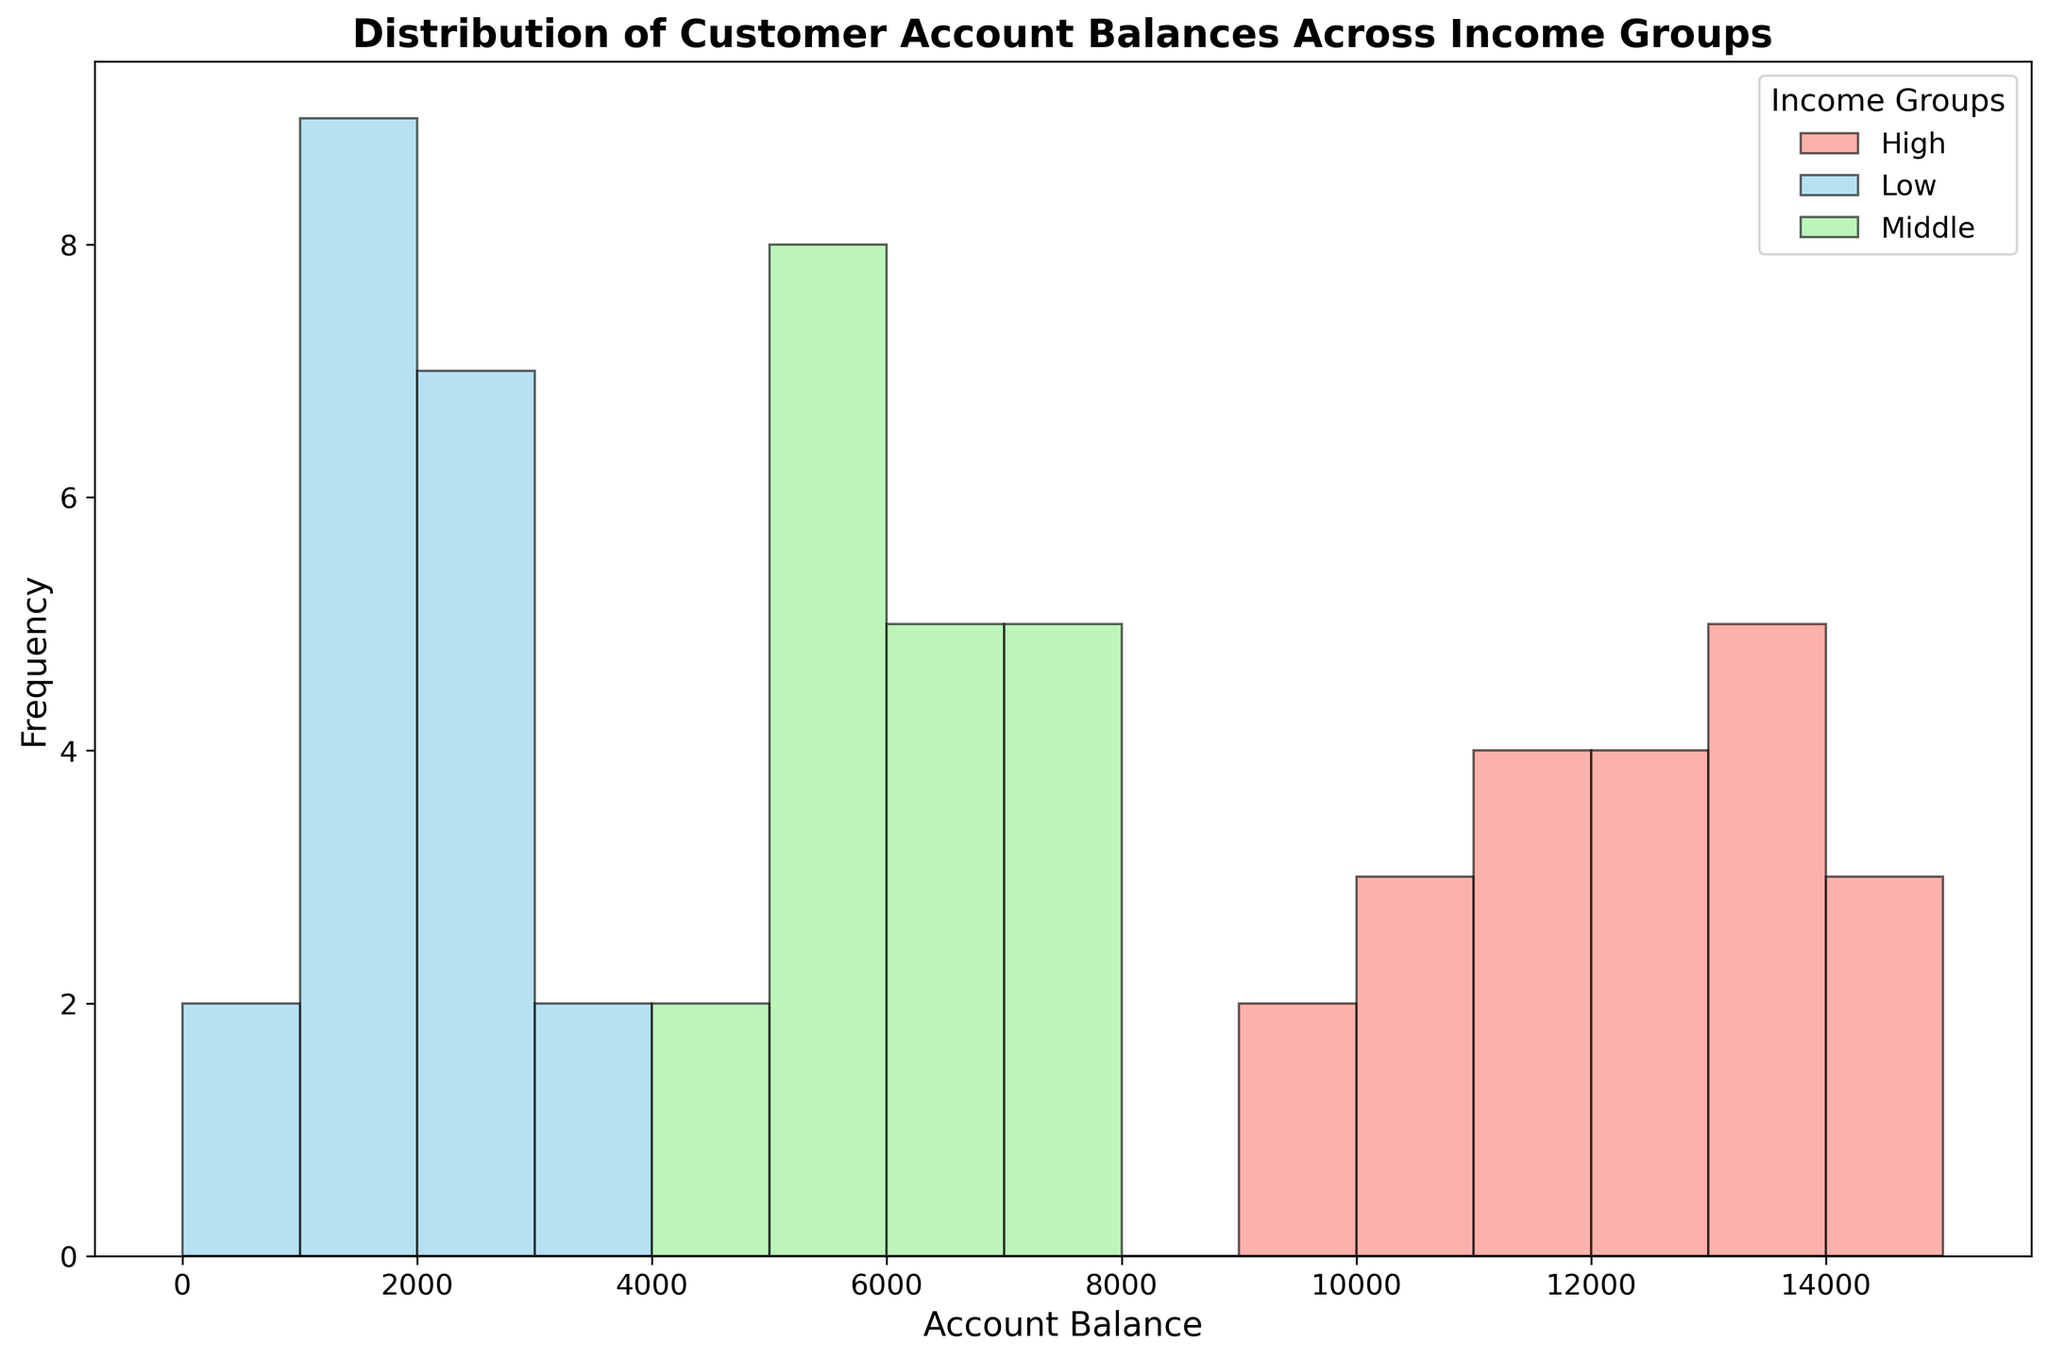What is the most frequent account balance range for the Low income group? To determine the most frequent account balance range, look at the tallest bars in the histogram for the Low income group (skyblue color). The tallest bars are between the 1000-2000 balance range.
Answer: 1000-2000 Which income group has the widest spread of account balances? To identify the widest spread, observe the range of account balances covered by each income group on the x-axis. The High income group (salmon color) covers balances from 9500 to 14500, which is the widest range.
Answer: High How does the peak frequency of the Middle income group's account balances compare to that of the Low income group? Compare the height of the tallest bars of the Middle (lightgreen) and Low (skyblue) income groups. The tallest bar of the Middle income group is higher than that of the Low income group.
Answer: Higher What is the combined frequency of account balances above 10,000 for the High income group? Count the total heights of the bars above the 10,000 mark for the High income group (salmon color). The combined frequency is 11.
Answer: 11 Is there any overlap in account balances between the Low and Middle income groups? Check if there are common balance ranges that both the Low (skyblue) and Middle (lightgreen) income groups share on the histogram. Both groups show account balances between 3000 to 3100.
Answer: Yes What is the average account balance within the Middle income group based on the histogram? Visually estimate the middle value of the account range for the Middle income group (lightgreen color). Account balances range between 4500 to 7500, so the average would be (4500+7500)/2 = 6000.
Answer: 6000 Which income group appears to have more uniformly distributed account balances? Assess the distribution of account balances for each income group. Middle income group (lightgreen) has more evenly distributed balances across its range compared to Low and High groups.
Answer: Middle What is the range of account balances for the Low income group? Observe the lowest and highest account balance tick marks for the Low income group (skyblue). The range is from 500 to 3100.
Answer: 500-3100 